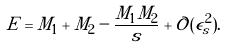Convert formula to latex. <formula><loc_0><loc_0><loc_500><loc_500>E = M _ { 1 } + M _ { 2 } - \frac { M _ { 1 } M _ { 2 } } { s } + { \mathcal { O } } ( \epsilon _ { s } ^ { 2 } ) .</formula> 